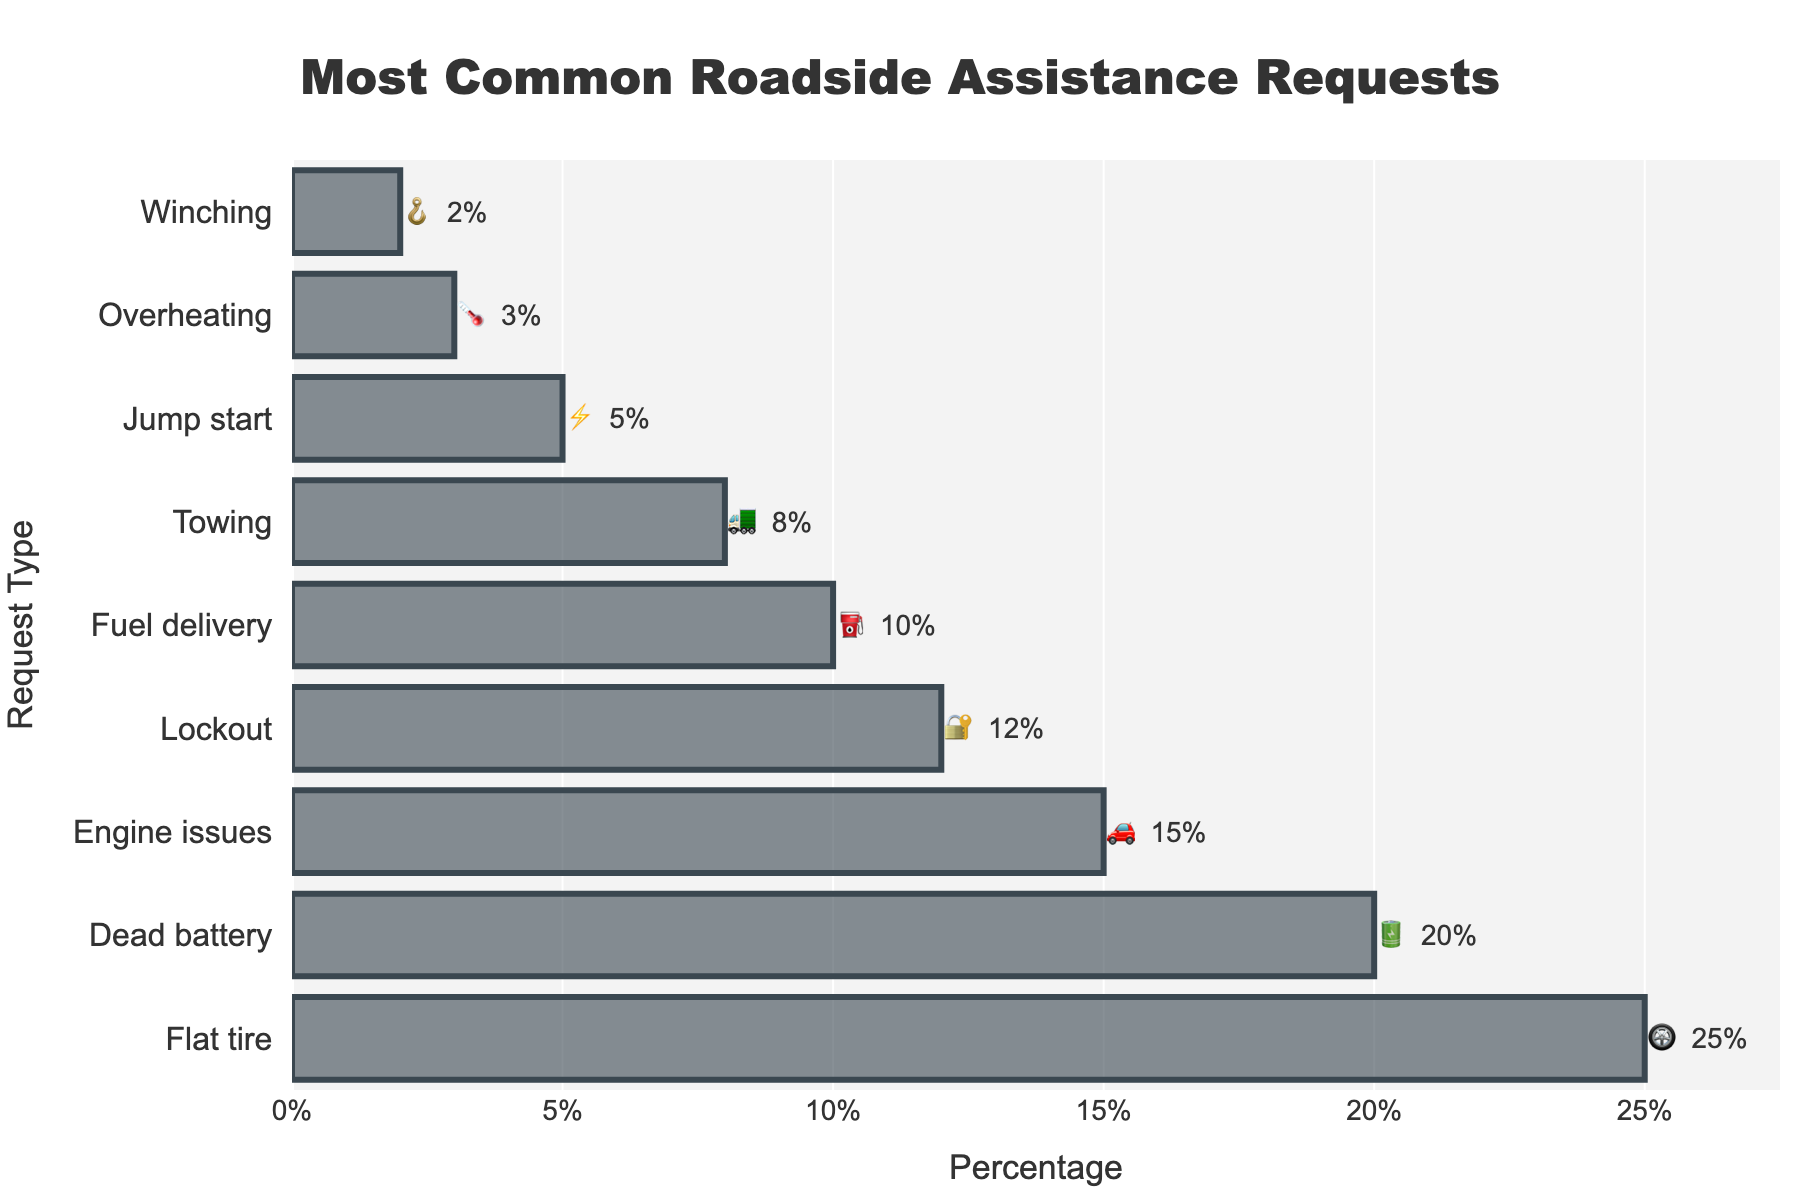What is the title of the figure? The title of the figure is clearly displayed at the top and centered. It reads: "Most Common Roadside Assistance Requests".
Answer: Most Common Roadside Assistance Requests Which roadside assistance request is the most common? The figure shows horizontal bars sorted by percentage, with the top bar representing the most common request. The top bar is labeled "Flat tire" with a percentage of 25%.
Answer: Flat tire What percentage of requests are for a dead battery? The bar and text for "Dead battery" indicate a percentage of 20%, visible next to the corresponding emoji.
Answer: 20% How many types of requests have a percentage greater than or equal to 10%? Count the number of bars with percentages displayed as 10% or higher. These requests are: Flat tire (25%), Dead battery (20%), Engine issues (15%), Lockout (12%), and Fuel delivery (10%). There are 5 such requests.
Answer: 5 Which request has the lowest percentage? The smallest bar at the bottom of the chart corresponds to "Winching", shown with a percentage of 2%.
Answer: Winching What is the combined percentage of fuel delivery and towing requests? Add the percentages for fuel delivery and towing: 10% + 8% = 18%.
Answer: 18% How much higher is the percentage of flat tire requests compared to jump start requests? Subtract the percentage for jump start (5%) from the percentage for flat tire (25%): 25% - 5% = 20%.
Answer: 20% Which two requests have the closest percentage values? By examining the percentages, the closest values are "Lockout" at 12% and "Fuel delivery" at 10%, with a difference of 2%.
Answer: Lockout and Fuel delivery If we categorize the requests into high (>15%), medium (10-15%), and low (<10%) percentages, how many requests fall into each category? High: Flat tire (25%), Dead battery (20%) - Total 2; Medium: Engine issues (15%), Lockout (12%), Fuel delivery (10%) - Total 3; Low: Towing (8%), Jump start (5%), Overheating (3%), Winching (2%) - Total 4.
Answer: High: 2, Medium: 3, Low: 4 